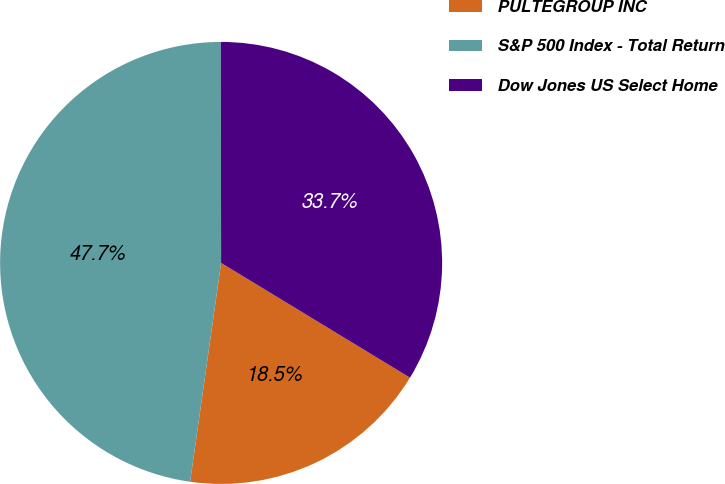Convert chart to OTSL. <chart><loc_0><loc_0><loc_500><loc_500><pie_chart><fcel>PULTEGROUP INC<fcel>S&P 500 Index - Total Return<fcel>Dow Jones US Select Home<nl><fcel>18.55%<fcel>47.74%<fcel>33.71%<nl></chart> 